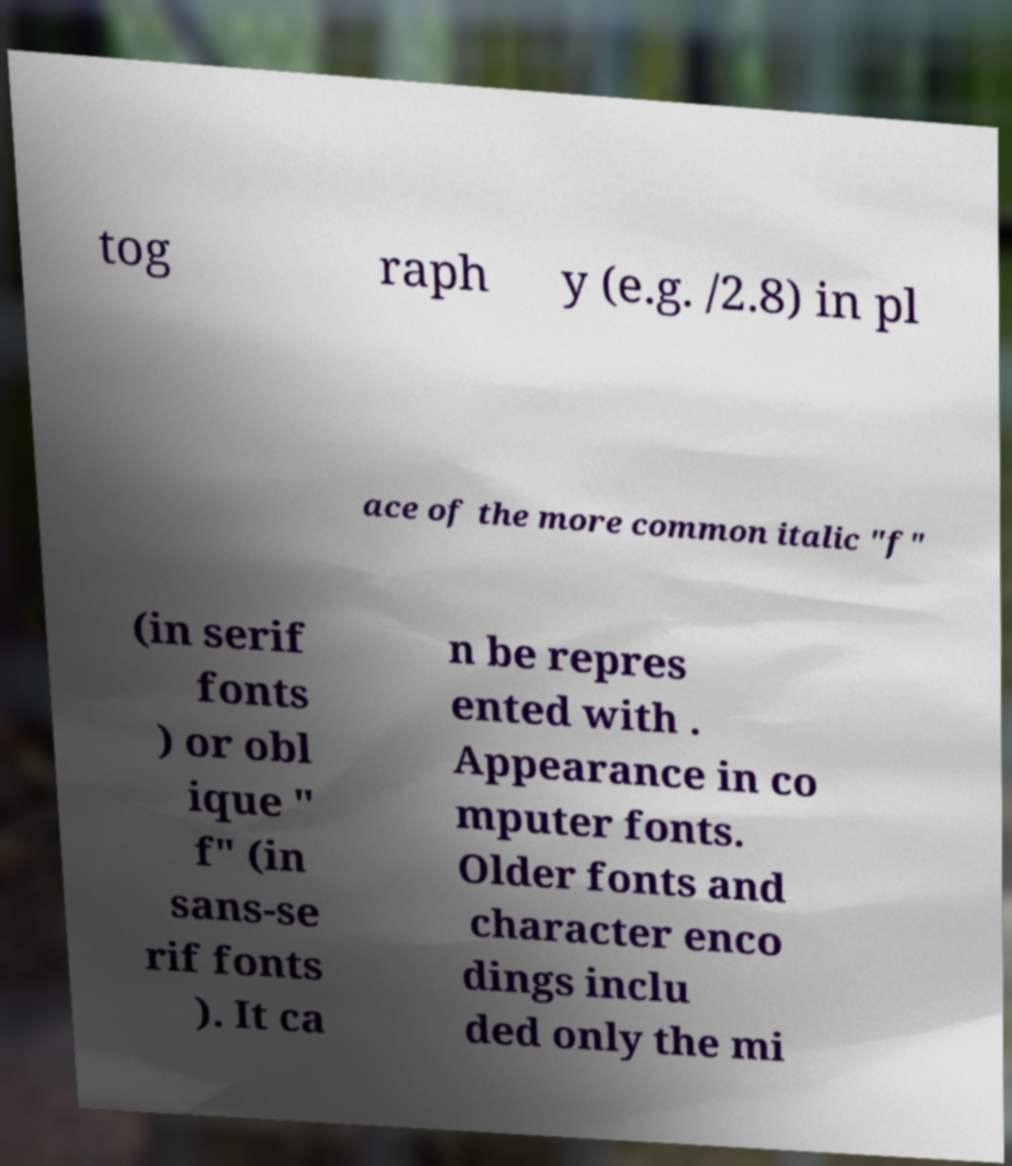Please read and relay the text visible in this image. What does it say? tog raph y (e.g. /2.8) in pl ace of the more common italic "f" (in serif fonts ) or obl ique " f" (in sans-se rif fonts ). It ca n be repres ented with . Appearance in co mputer fonts. Older fonts and character enco dings inclu ded only the mi 